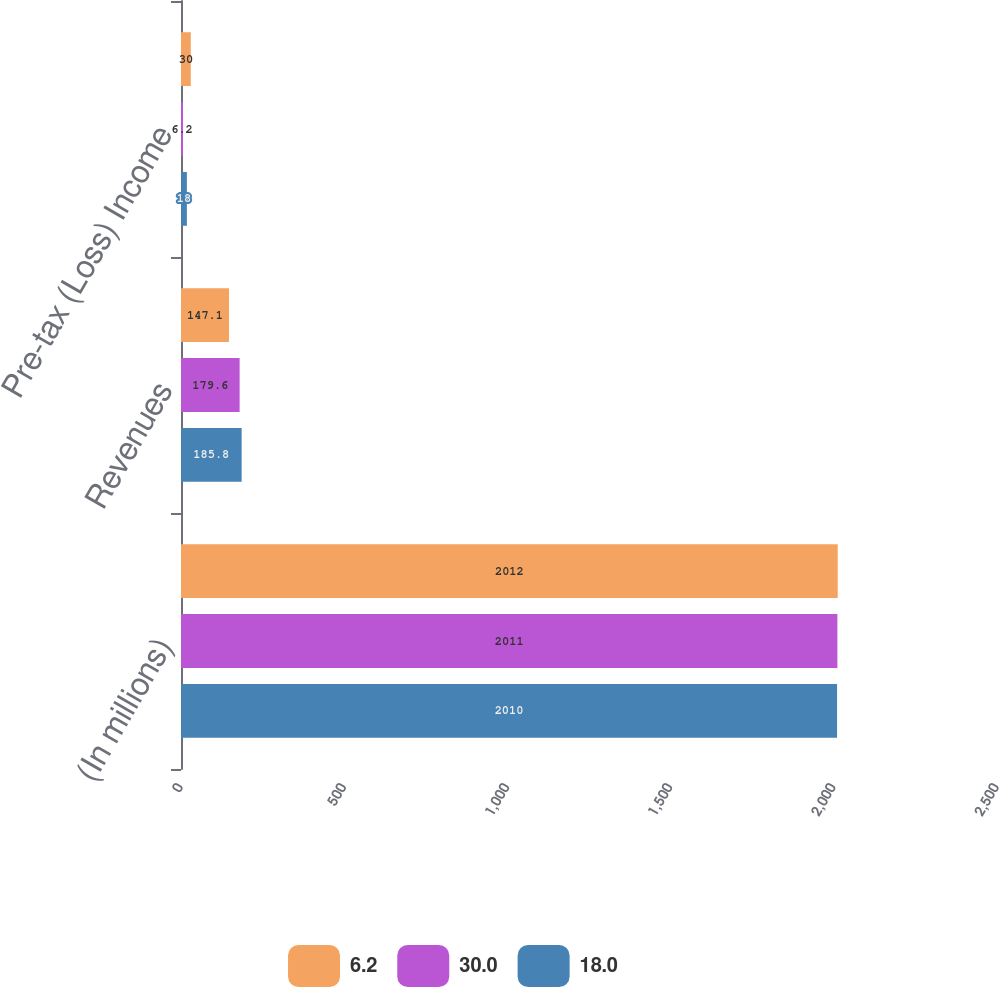<chart> <loc_0><loc_0><loc_500><loc_500><stacked_bar_chart><ecel><fcel>(In millions)<fcel>Revenues<fcel>Pre-tax (Loss) Income<nl><fcel>6.2<fcel>2012<fcel>147.1<fcel>30<nl><fcel>30<fcel>2011<fcel>179.6<fcel>6.2<nl><fcel>18<fcel>2010<fcel>185.8<fcel>18<nl></chart> 